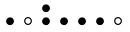Convert formula to latex. <formula><loc_0><loc_0><loc_500><loc_500>\begin{smallmatrix} & & \bullet \\ \bullet & \circ & \bullet & \bullet & \bullet & \bullet & \circ & \\ \end{smallmatrix}</formula> 